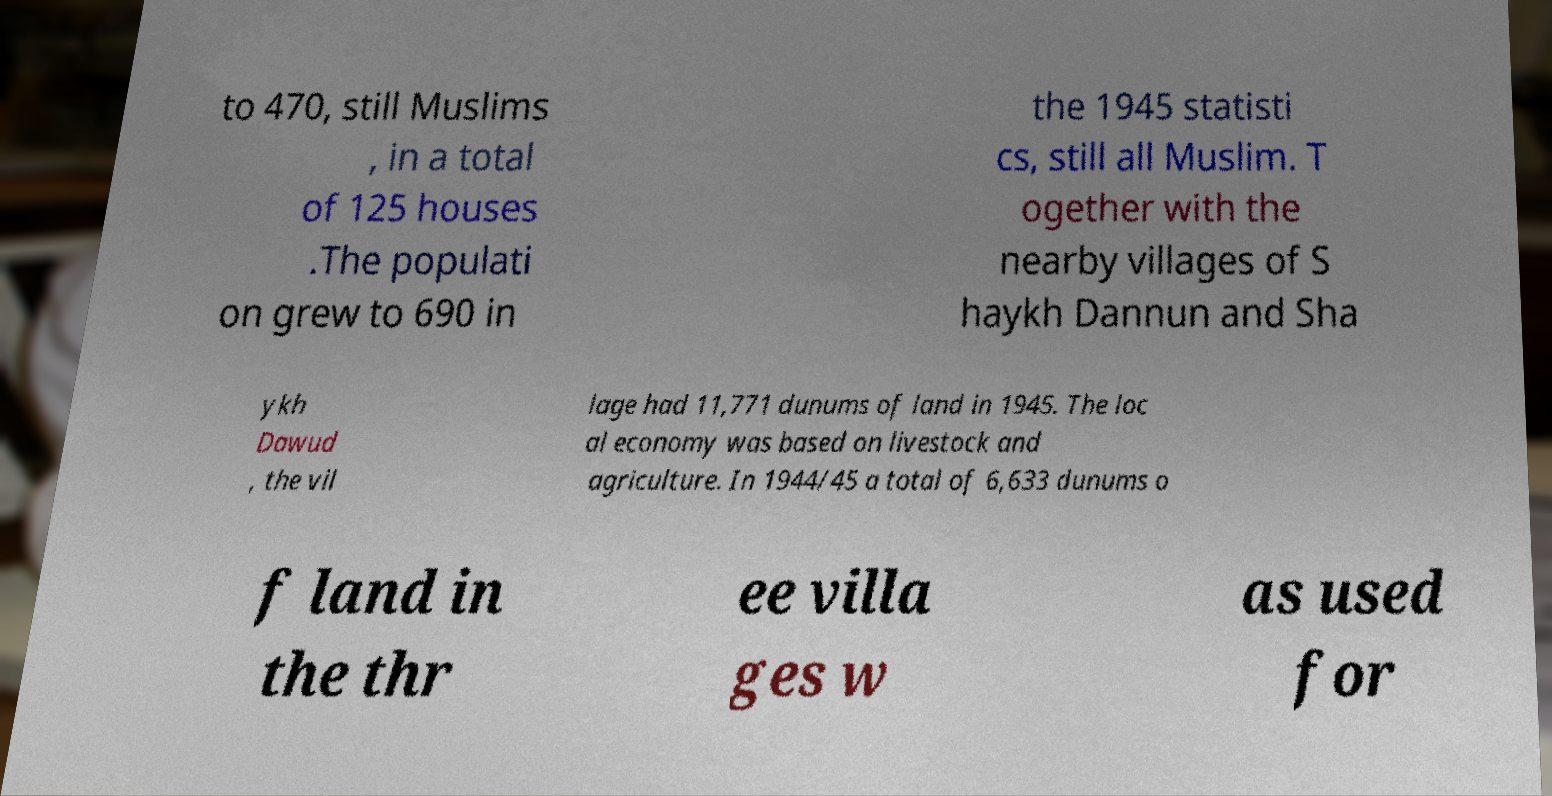Please identify and transcribe the text found in this image. to 470, still Muslims , in a total of 125 houses .The populati on grew to 690 in the 1945 statisti cs, still all Muslim. T ogether with the nearby villages of S haykh Dannun and Sha ykh Dawud , the vil lage had 11,771 dunums of land in 1945. The loc al economy was based on livestock and agriculture. In 1944/45 a total of 6,633 dunums o f land in the thr ee villa ges w as used for 